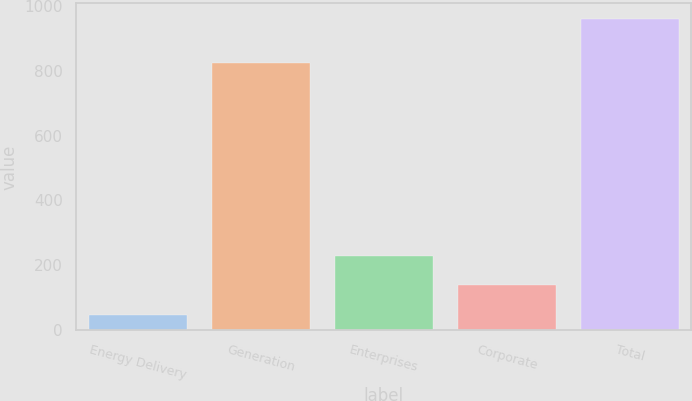<chart> <loc_0><loc_0><loc_500><loc_500><bar_chart><fcel>Energy Delivery<fcel>Generation<fcel>Enterprises<fcel>Corporate<fcel>Total<nl><fcel>47<fcel>824<fcel>229.4<fcel>138.2<fcel>959<nl></chart> 